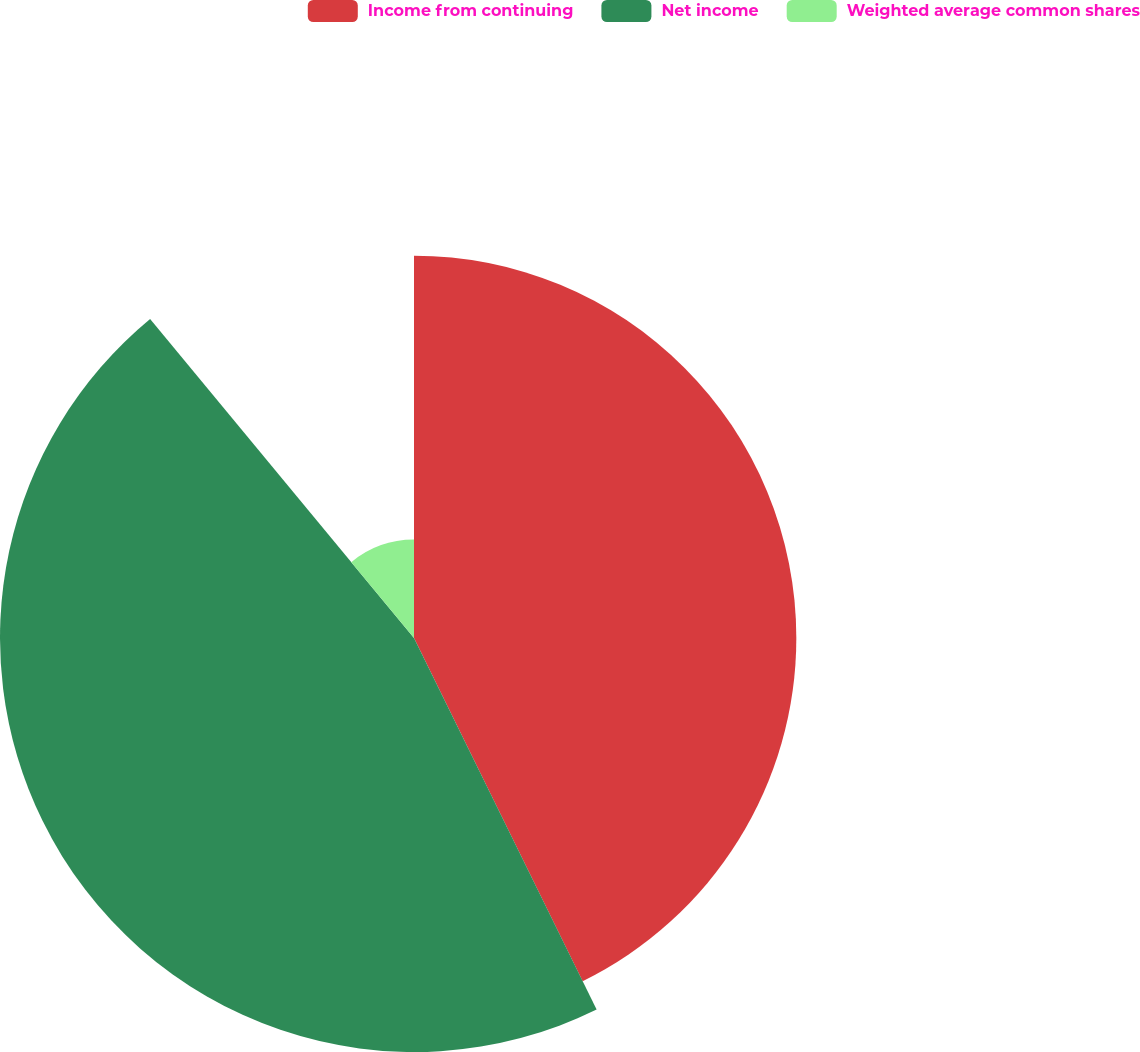Convert chart. <chart><loc_0><loc_0><loc_500><loc_500><pie_chart><fcel>Income from continuing<fcel>Net income<fcel>Weighted average common shares<nl><fcel>42.73%<fcel>46.27%<fcel>11.0%<nl></chart> 